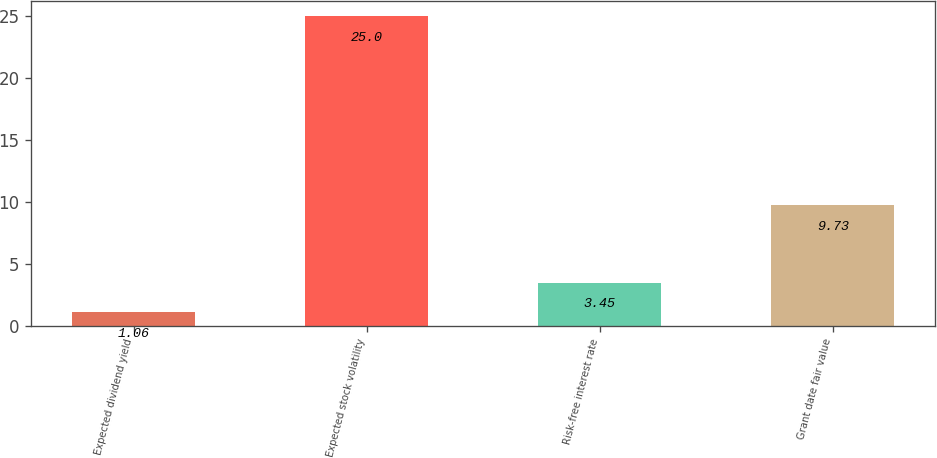Convert chart. <chart><loc_0><loc_0><loc_500><loc_500><bar_chart><fcel>Expected dividend yield<fcel>Expected stock volatility<fcel>Risk-free interest rate<fcel>Grant date fair value<nl><fcel>1.06<fcel>25<fcel>3.45<fcel>9.73<nl></chart> 